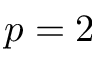Convert formula to latex. <formula><loc_0><loc_0><loc_500><loc_500>p = 2</formula> 